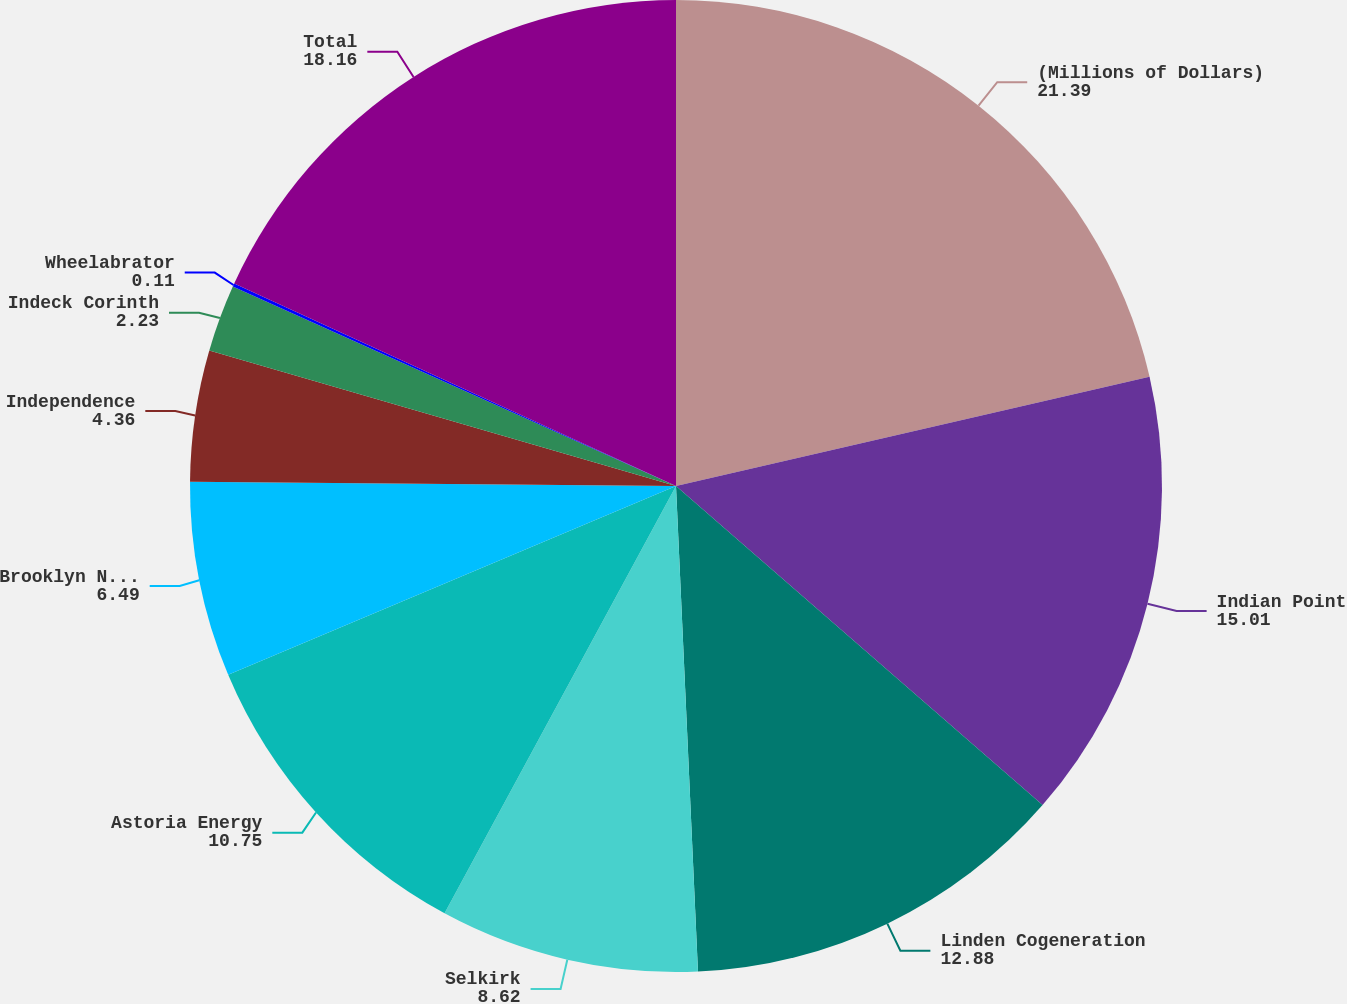Convert chart. <chart><loc_0><loc_0><loc_500><loc_500><pie_chart><fcel>(Millions of Dollars)<fcel>Indian Point<fcel>Linden Cogeneration<fcel>Selkirk<fcel>Astoria Energy<fcel>Brooklyn Navy Yard<fcel>Independence<fcel>Indeck Corinth<fcel>Wheelabrator<fcel>Total<nl><fcel>21.39%<fcel>15.01%<fcel>12.88%<fcel>8.62%<fcel>10.75%<fcel>6.49%<fcel>4.36%<fcel>2.23%<fcel>0.11%<fcel>18.16%<nl></chart> 